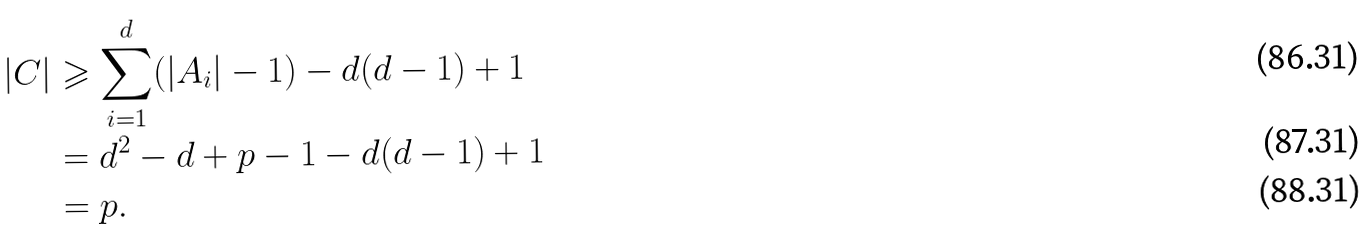<formula> <loc_0><loc_0><loc_500><loc_500>| C | & \geqslant \sum _ { i = 1 } ^ { d } ( | A _ { i } | - 1 ) - d ( d - 1 ) + 1 \\ & = d ^ { 2 } - d + p - 1 - d ( d - 1 ) + 1 \\ & = p .</formula> 